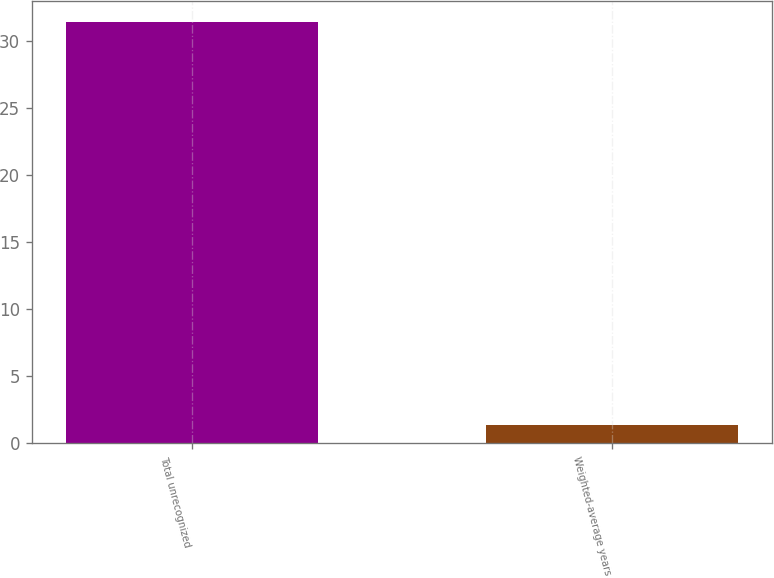Convert chart to OTSL. <chart><loc_0><loc_0><loc_500><loc_500><bar_chart><fcel>Total unrecognized<fcel>Weighted-average years<nl><fcel>31.4<fcel>1.4<nl></chart> 